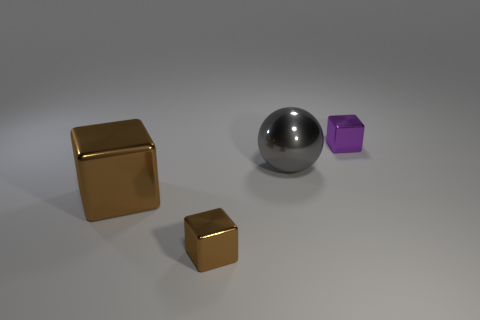Add 2 small cyan things. How many objects exist? 6 Subtract all balls. How many objects are left? 3 Add 1 red metal spheres. How many red metal spheres exist? 1 Subtract 0 brown spheres. How many objects are left? 4 Subtract all purple metal cubes. Subtract all gray metal balls. How many objects are left? 2 Add 2 metal spheres. How many metal spheres are left? 3 